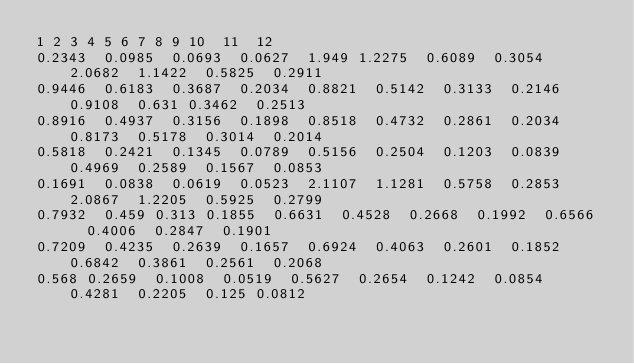<code> <loc_0><loc_0><loc_500><loc_500><_SQL_>1	2	3	4	5	6	7	8	9	10	11	12
0.2343	0.0985	0.0693	0.0627	1.949	1.2275	0.6089	0.3054	2.0682	1.1422	0.5825	0.2911
0.9446	0.6183	0.3687	0.2034	0.8821	0.5142	0.3133	0.2146	0.9108	0.631	0.3462	0.2513
0.8916	0.4937	0.3156	0.1898	0.8518	0.4732	0.2861	0.2034	0.8173	0.5178	0.3014	0.2014
0.5818	0.2421	0.1345	0.0789	0.5156	0.2504	0.1203	0.0839	0.4969	0.2589	0.1567	0.0853
0.1691	0.0838	0.0619	0.0523	2.1107	1.1281	0.5758	0.2853	2.0867	1.2205	0.5925	0.2799
0.7932	0.459	0.313	0.1855	0.6631	0.4528	0.2668	0.1992	0.6566	0.4006	0.2847	0.1901
0.7209	0.4235	0.2639	0.1657	0.6924	0.4063	0.2601	0.1852	0.6842	0.3861	0.2561	0.2068
0.568	0.2659	0.1008	0.0519	0.5627	0.2654	0.1242	0.0854	0.4281	0.2205	0.125	0.0812
</code> 